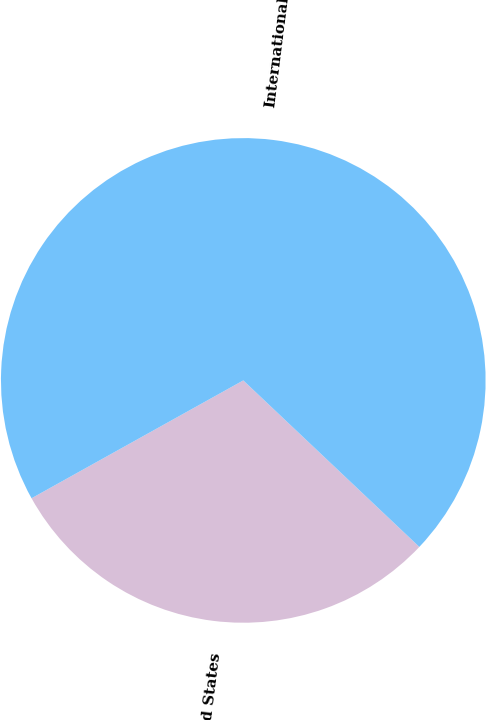Convert chart. <chart><loc_0><loc_0><loc_500><loc_500><pie_chart><fcel>United States<fcel>International<nl><fcel>29.86%<fcel>70.14%<nl></chart> 